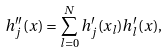Convert formula to latex. <formula><loc_0><loc_0><loc_500><loc_500>h _ { j } ^ { \prime \prime } ( x ) = \sum _ { l = 0 } ^ { N } h _ { j } ^ { \prime } ( x _ { l } ) h _ { l } ^ { \prime } ( x ) ,</formula> 